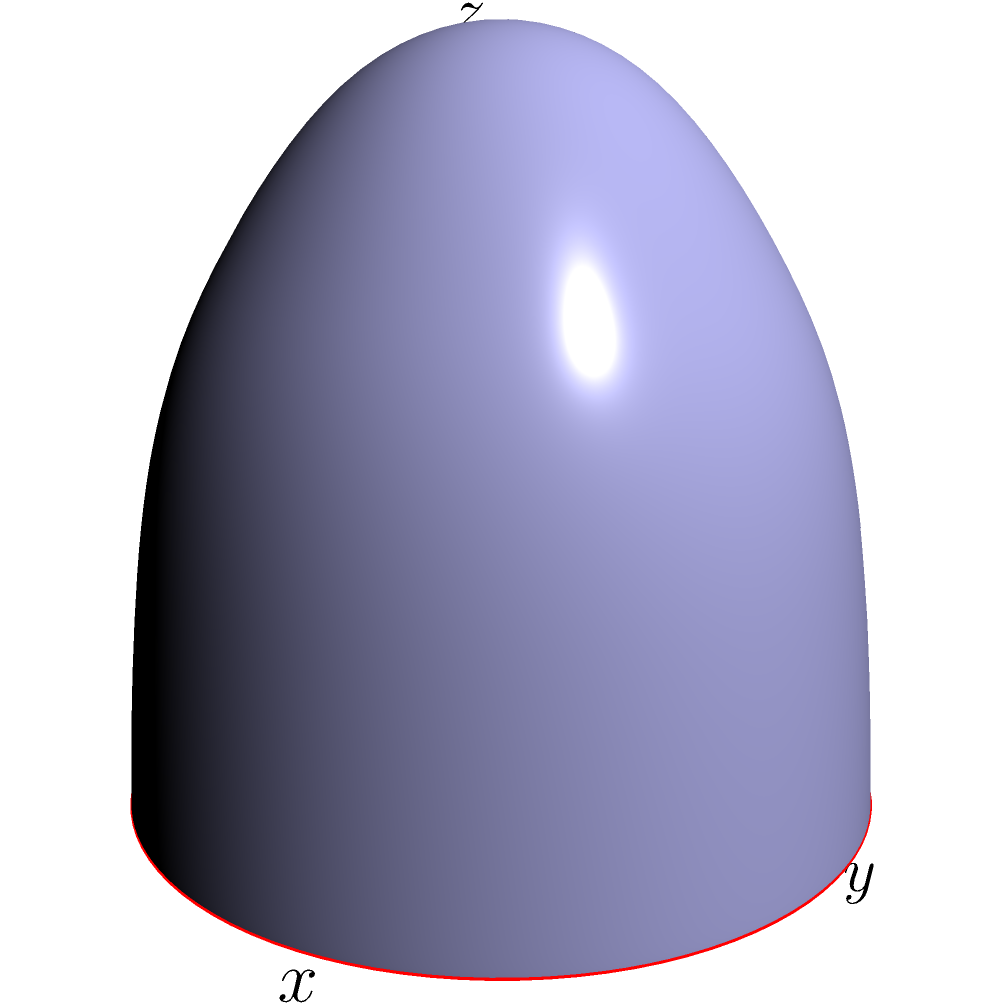Consider a 3D manifold representing a sphere in $\mathbb{R}^3$ given by the parametric equations:

$$x = 2\cos u \cos v$$
$$y = 2\sin u \cos v$$
$$z = \sin v$$

where $0 \leq u < 2\pi$ and $-\frac{\pi}{2} \leq v \leq \frac{\pi}{2}$. 

What is the equation of the orthographic projection of this manifold onto the xy-plane, and what does this projection represent geometrically? To solve this problem, we'll follow these steps:

1) Orthographic projection onto the xy-plane means we're simply ignoring the z-coordinate. So we only need to consider the equations for x and y.

2) From the given parametric equations, we have:
   $$x = 2\cos u \cos v$$
   $$y = 2\sin u \cos v$$

3) To eliminate the parameters and find the Cartesian equation of the projection, we can square and add these equations:

   $$\frac{x^2}{4} + \frac{y^2}{4} = \cos^2 u \cos^2 v + \sin^2 u \cos^2 v$$

4) Using the trigonometric identity $\cos^2 u + \sin^2 u = 1$, we get:

   $$\frac{x^2}{4} + \frac{y^2}{4} = \cos^2 v$$

5) Note that $\cos^2 v \leq 1$ for all v. This means:

   $$\frac{x^2}{4} + \frac{y^2}{4} \leq 1$$

6) This is the equation of a circle with radius 2 centered at the origin.

Geometrically, this projection represents the "shadow" of the sphere when light shines directly down the z-axis. It's a filled circle because every point on the sphere (except the poles) projects to a unique point within this circle, and the poles project to the edge of the circle.
Answer: $\frac{x^2}{4} + \frac{y^2}{4} \leq 1$; a filled circle of radius 2 